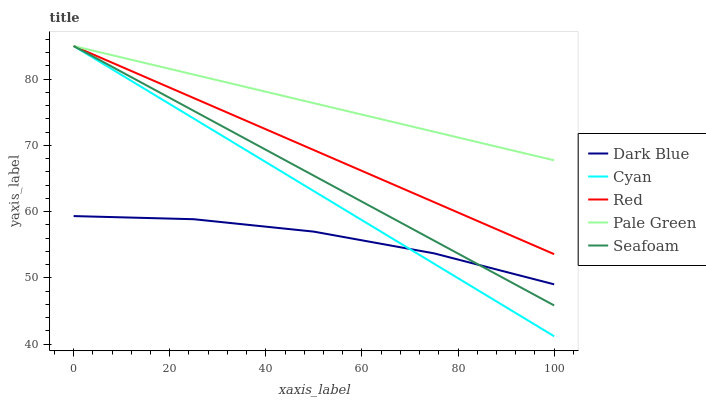Does Dark Blue have the minimum area under the curve?
Answer yes or no. Yes. Does Pale Green have the maximum area under the curve?
Answer yes or no. Yes. Does Seafoam have the minimum area under the curve?
Answer yes or no. No. Does Seafoam have the maximum area under the curve?
Answer yes or no. No. Is Cyan the smoothest?
Answer yes or no. Yes. Is Dark Blue the roughest?
Answer yes or no. Yes. Is Pale Green the smoothest?
Answer yes or no. No. Is Pale Green the roughest?
Answer yes or no. No. Does Cyan have the lowest value?
Answer yes or no. Yes. Does Seafoam have the lowest value?
Answer yes or no. No. Does Cyan have the highest value?
Answer yes or no. Yes. Is Dark Blue less than Pale Green?
Answer yes or no. Yes. Is Red greater than Dark Blue?
Answer yes or no. Yes. Does Seafoam intersect Dark Blue?
Answer yes or no. Yes. Is Seafoam less than Dark Blue?
Answer yes or no. No. Is Seafoam greater than Dark Blue?
Answer yes or no. No. Does Dark Blue intersect Pale Green?
Answer yes or no. No. 